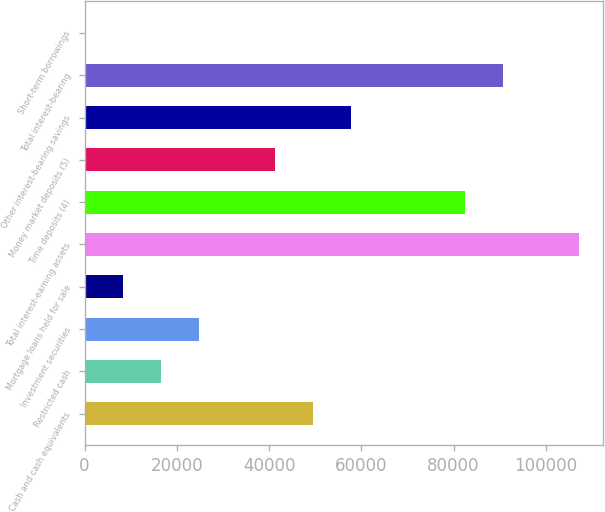Convert chart to OTSL. <chart><loc_0><loc_0><loc_500><loc_500><bar_chart><fcel>Cash and cash equivalents<fcel>Restricted cash<fcel>Investment securities<fcel>Mortgage loans held for sale<fcel>Total interest-earning assets<fcel>Time deposits (4)<fcel>Money market deposits (5)<fcel>Other interest-bearing savings<fcel>Total interest-bearing<fcel>Short-term borrowings<nl><fcel>49478.4<fcel>16548.8<fcel>24781.2<fcel>8316.4<fcel>107105<fcel>82408<fcel>41246<fcel>57710.8<fcel>90640.4<fcel>84<nl></chart> 